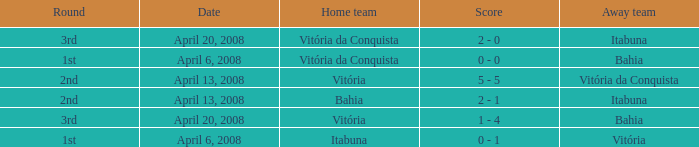Who played as the home team when Vitória was the away team? Itabuna. 